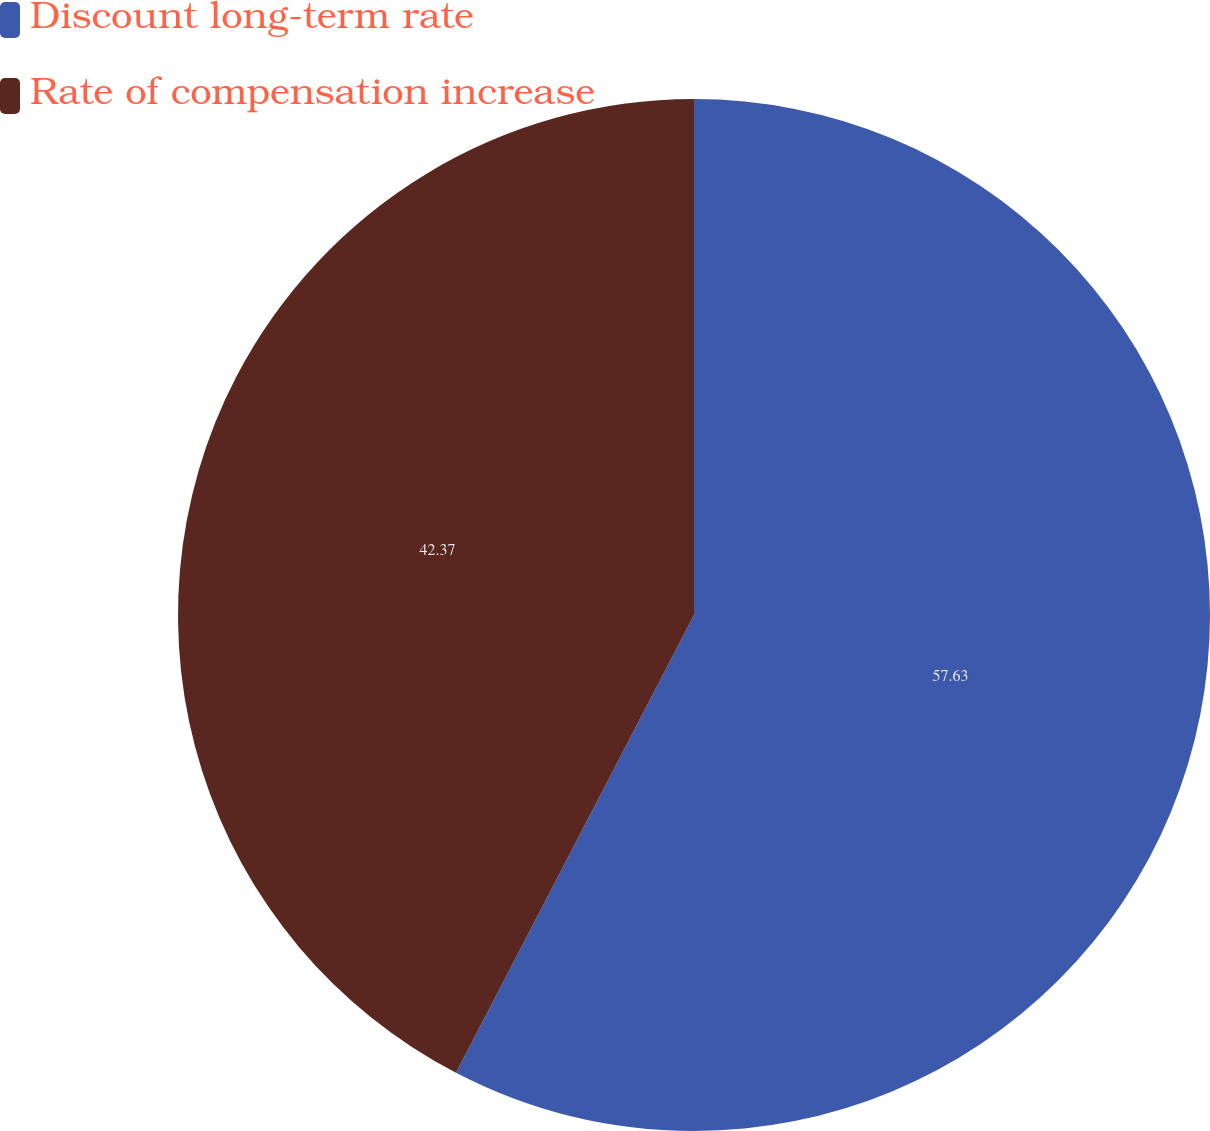Convert chart to OTSL. <chart><loc_0><loc_0><loc_500><loc_500><pie_chart><fcel>Discount long-term rate<fcel>Rate of compensation increase<nl><fcel>57.63%<fcel>42.37%<nl></chart> 